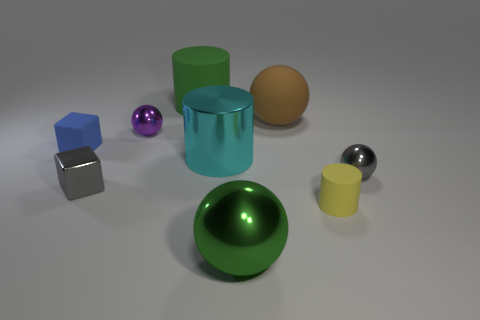Is the color of the big matte cylinder the same as the large metal sphere?
Make the answer very short. Yes. Is there any other thing that has the same material as the small gray block?
Provide a short and direct response. Yes. How many things are either blue objects in front of the brown matte sphere or tiny blue cubes?
Keep it short and to the point. 1. There is a large green object behind the metal object behind the small blue matte object; are there any green cylinders in front of it?
Offer a terse response. No. What number of green matte cylinders are there?
Ensure brevity in your answer.  1. What number of things are matte cylinders that are to the left of the green shiny thing or objects behind the gray block?
Provide a succinct answer. 6. There is a matte cylinder behind the shiny cylinder; is it the same size as the large cyan cylinder?
Keep it short and to the point. Yes. What is the size of the matte object that is the same shape as the big green metallic thing?
Ensure brevity in your answer.  Large. There is a gray ball that is the same size as the matte cube; what material is it?
Offer a terse response. Metal. There is a small yellow object that is the same shape as the cyan thing; what material is it?
Offer a very short reply. Rubber. 